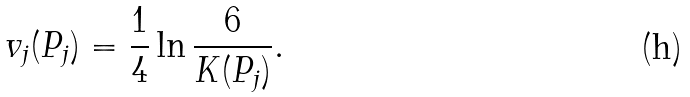Convert formula to latex. <formula><loc_0><loc_0><loc_500><loc_500>v _ { j } ( P _ { j } ) = \frac { 1 } { 4 } \ln \frac { 6 } { K ( P _ { j } ) } .</formula> 